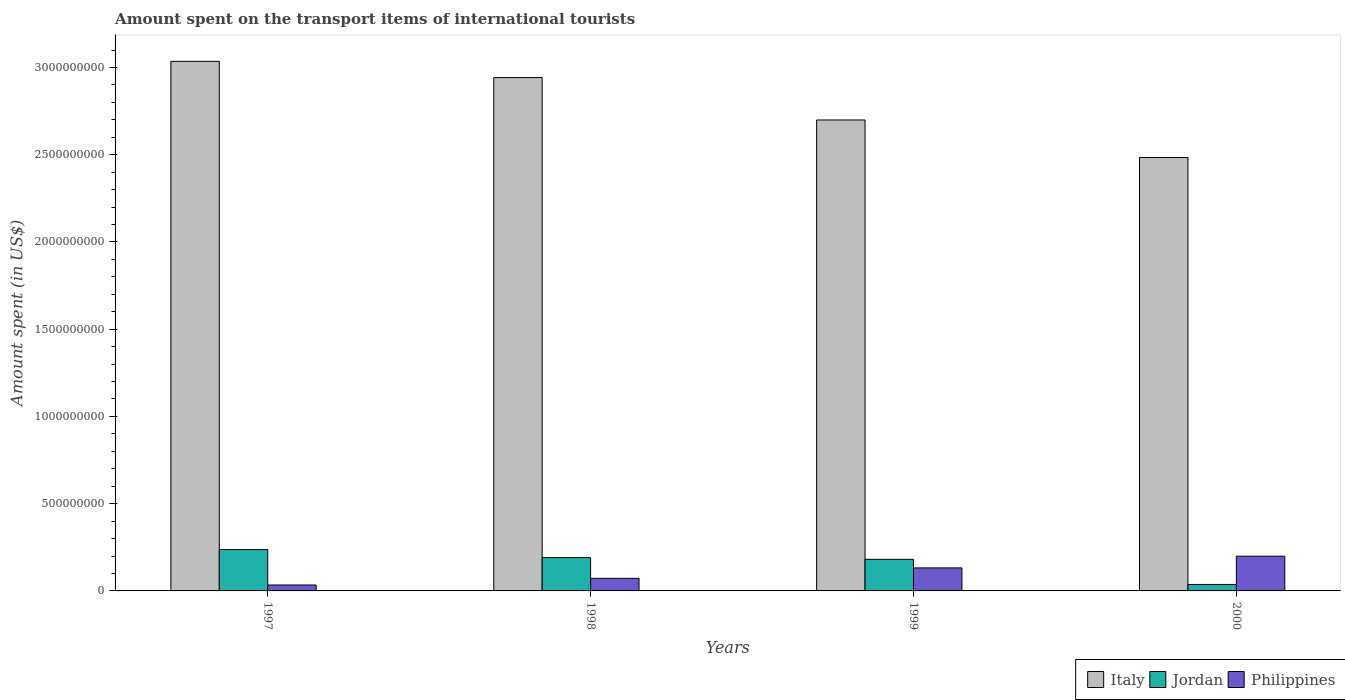How many groups of bars are there?
Provide a succinct answer. 4. Are the number of bars on each tick of the X-axis equal?
Provide a short and direct response. Yes. What is the label of the 3rd group of bars from the left?
Your response must be concise. 1999. What is the amount spent on the transport items of international tourists in Philippines in 1999?
Ensure brevity in your answer.  1.32e+08. Across all years, what is the maximum amount spent on the transport items of international tourists in Italy?
Give a very brief answer. 3.04e+09. Across all years, what is the minimum amount spent on the transport items of international tourists in Jordan?
Provide a short and direct response. 3.70e+07. In which year was the amount spent on the transport items of international tourists in Jordan maximum?
Provide a succinct answer. 1997. What is the total amount spent on the transport items of international tourists in Jordan in the graph?
Your answer should be very brief. 6.46e+08. What is the difference between the amount spent on the transport items of international tourists in Jordan in 1997 and that in 2000?
Provide a succinct answer. 2.00e+08. What is the difference between the amount spent on the transport items of international tourists in Jordan in 1997 and the amount spent on the transport items of international tourists in Italy in 1998?
Your answer should be compact. -2.70e+09. What is the average amount spent on the transport items of international tourists in Italy per year?
Make the answer very short. 2.79e+09. In the year 2000, what is the difference between the amount spent on the transport items of international tourists in Philippines and amount spent on the transport items of international tourists in Italy?
Give a very brief answer. -2.28e+09. What is the ratio of the amount spent on the transport items of international tourists in Philippines in 1998 to that in 1999?
Make the answer very short. 0.55. Is the difference between the amount spent on the transport items of international tourists in Philippines in 1998 and 2000 greater than the difference between the amount spent on the transport items of international tourists in Italy in 1998 and 2000?
Make the answer very short. No. What is the difference between the highest and the second highest amount spent on the transport items of international tourists in Jordan?
Make the answer very short. 4.60e+07. What is the difference between the highest and the lowest amount spent on the transport items of international tourists in Jordan?
Provide a short and direct response. 2.00e+08. What does the 1st bar from the right in 1998 represents?
Your answer should be compact. Philippines. Are all the bars in the graph horizontal?
Offer a very short reply. No. How many years are there in the graph?
Make the answer very short. 4. Are the values on the major ticks of Y-axis written in scientific E-notation?
Keep it short and to the point. No. How many legend labels are there?
Offer a terse response. 3. What is the title of the graph?
Your answer should be very brief. Amount spent on the transport items of international tourists. What is the label or title of the Y-axis?
Give a very brief answer. Amount spent (in US$). What is the Amount spent (in US$) in Italy in 1997?
Give a very brief answer. 3.04e+09. What is the Amount spent (in US$) in Jordan in 1997?
Give a very brief answer. 2.37e+08. What is the Amount spent (in US$) in Philippines in 1997?
Ensure brevity in your answer.  3.40e+07. What is the Amount spent (in US$) of Italy in 1998?
Your answer should be compact. 2.94e+09. What is the Amount spent (in US$) in Jordan in 1998?
Give a very brief answer. 1.91e+08. What is the Amount spent (in US$) in Philippines in 1998?
Your answer should be very brief. 7.20e+07. What is the Amount spent (in US$) of Italy in 1999?
Offer a very short reply. 2.70e+09. What is the Amount spent (in US$) of Jordan in 1999?
Offer a very short reply. 1.81e+08. What is the Amount spent (in US$) of Philippines in 1999?
Offer a terse response. 1.32e+08. What is the Amount spent (in US$) in Italy in 2000?
Offer a terse response. 2.48e+09. What is the Amount spent (in US$) in Jordan in 2000?
Give a very brief answer. 3.70e+07. What is the Amount spent (in US$) in Philippines in 2000?
Offer a very short reply. 1.99e+08. Across all years, what is the maximum Amount spent (in US$) in Italy?
Your response must be concise. 3.04e+09. Across all years, what is the maximum Amount spent (in US$) in Jordan?
Make the answer very short. 2.37e+08. Across all years, what is the maximum Amount spent (in US$) in Philippines?
Ensure brevity in your answer.  1.99e+08. Across all years, what is the minimum Amount spent (in US$) in Italy?
Your answer should be compact. 2.48e+09. Across all years, what is the minimum Amount spent (in US$) in Jordan?
Offer a very short reply. 3.70e+07. Across all years, what is the minimum Amount spent (in US$) in Philippines?
Your answer should be very brief. 3.40e+07. What is the total Amount spent (in US$) of Italy in the graph?
Offer a very short reply. 1.12e+1. What is the total Amount spent (in US$) in Jordan in the graph?
Make the answer very short. 6.46e+08. What is the total Amount spent (in US$) in Philippines in the graph?
Offer a very short reply. 4.37e+08. What is the difference between the Amount spent (in US$) in Italy in 1997 and that in 1998?
Your answer should be compact. 9.30e+07. What is the difference between the Amount spent (in US$) of Jordan in 1997 and that in 1998?
Your answer should be compact. 4.60e+07. What is the difference between the Amount spent (in US$) of Philippines in 1997 and that in 1998?
Your response must be concise. -3.80e+07. What is the difference between the Amount spent (in US$) of Italy in 1997 and that in 1999?
Provide a succinct answer. 3.36e+08. What is the difference between the Amount spent (in US$) in Jordan in 1997 and that in 1999?
Keep it short and to the point. 5.60e+07. What is the difference between the Amount spent (in US$) in Philippines in 1997 and that in 1999?
Provide a short and direct response. -9.80e+07. What is the difference between the Amount spent (in US$) of Italy in 1997 and that in 2000?
Provide a succinct answer. 5.51e+08. What is the difference between the Amount spent (in US$) of Philippines in 1997 and that in 2000?
Your response must be concise. -1.65e+08. What is the difference between the Amount spent (in US$) in Italy in 1998 and that in 1999?
Your answer should be very brief. 2.43e+08. What is the difference between the Amount spent (in US$) in Jordan in 1998 and that in 1999?
Your response must be concise. 1.00e+07. What is the difference between the Amount spent (in US$) in Philippines in 1998 and that in 1999?
Your response must be concise. -6.00e+07. What is the difference between the Amount spent (in US$) of Italy in 1998 and that in 2000?
Ensure brevity in your answer.  4.58e+08. What is the difference between the Amount spent (in US$) of Jordan in 1998 and that in 2000?
Make the answer very short. 1.54e+08. What is the difference between the Amount spent (in US$) in Philippines in 1998 and that in 2000?
Make the answer very short. -1.27e+08. What is the difference between the Amount spent (in US$) in Italy in 1999 and that in 2000?
Provide a short and direct response. 2.15e+08. What is the difference between the Amount spent (in US$) in Jordan in 1999 and that in 2000?
Your answer should be compact. 1.44e+08. What is the difference between the Amount spent (in US$) in Philippines in 1999 and that in 2000?
Your answer should be compact. -6.70e+07. What is the difference between the Amount spent (in US$) in Italy in 1997 and the Amount spent (in US$) in Jordan in 1998?
Your answer should be very brief. 2.84e+09. What is the difference between the Amount spent (in US$) in Italy in 1997 and the Amount spent (in US$) in Philippines in 1998?
Your answer should be compact. 2.96e+09. What is the difference between the Amount spent (in US$) of Jordan in 1997 and the Amount spent (in US$) of Philippines in 1998?
Your response must be concise. 1.65e+08. What is the difference between the Amount spent (in US$) in Italy in 1997 and the Amount spent (in US$) in Jordan in 1999?
Your answer should be compact. 2.85e+09. What is the difference between the Amount spent (in US$) in Italy in 1997 and the Amount spent (in US$) in Philippines in 1999?
Ensure brevity in your answer.  2.90e+09. What is the difference between the Amount spent (in US$) in Jordan in 1997 and the Amount spent (in US$) in Philippines in 1999?
Your answer should be compact. 1.05e+08. What is the difference between the Amount spent (in US$) in Italy in 1997 and the Amount spent (in US$) in Jordan in 2000?
Your answer should be very brief. 3.00e+09. What is the difference between the Amount spent (in US$) in Italy in 1997 and the Amount spent (in US$) in Philippines in 2000?
Provide a short and direct response. 2.84e+09. What is the difference between the Amount spent (in US$) of Jordan in 1997 and the Amount spent (in US$) of Philippines in 2000?
Offer a very short reply. 3.80e+07. What is the difference between the Amount spent (in US$) in Italy in 1998 and the Amount spent (in US$) in Jordan in 1999?
Offer a very short reply. 2.76e+09. What is the difference between the Amount spent (in US$) in Italy in 1998 and the Amount spent (in US$) in Philippines in 1999?
Offer a very short reply. 2.81e+09. What is the difference between the Amount spent (in US$) in Jordan in 1998 and the Amount spent (in US$) in Philippines in 1999?
Your answer should be very brief. 5.90e+07. What is the difference between the Amount spent (in US$) of Italy in 1998 and the Amount spent (in US$) of Jordan in 2000?
Provide a short and direct response. 2.90e+09. What is the difference between the Amount spent (in US$) in Italy in 1998 and the Amount spent (in US$) in Philippines in 2000?
Your answer should be very brief. 2.74e+09. What is the difference between the Amount spent (in US$) in Jordan in 1998 and the Amount spent (in US$) in Philippines in 2000?
Your response must be concise. -8.00e+06. What is the difference between the Amount spent (in US$) in Italy in 1999 and the Amount spent (in US$) in Jordan in 2000?
Provide a short and direct response. 2.66e+09. What is the difference between the Amount spent (in US$) of Italy in 1999 and the Amount spent (in US$) of Philippines in 2000?
Provide a short and direct response. 2.50e+09. What is the difference between the Amount spent (in US$) of Jordan in 1999 and the Amount spent (in US$) of Philippines in 2000?
Ensure brevity in your answer.  -1.80e+07. What is the average Amount spent (in US$) of Italy per year?
Provide a short and direct response. 2.79e+09. What is the average Amount spent (in US$) of Jordan per year?
Your response must be concise. 1.62e+08. What is the average Amount spent (in US$) in Philippines per year?
Ensure brevity in your answer.  1.09e+08. In the year 1997, what is the difference between the Amount spent (in US$) in Italy and Amount spent (in US$) in Jordan?
Provide a short and direct response. 2.80e+09. In the year 1997, what is the difference between the Amount spent (in US$) in Italy and Amount spent (in US$) in Philippines?
Give a very brief answer. 3.00e+09. In the year 1997, what is the difference between the Amount spent (in US$) in Jordan and Amount spent (in US$) in Philippines?
Provide a short and direct response. 2.03e+08. In the year 1998, what is the difference between the Amount spent (in US$) of Italy and Amount spent (in US$) of Jordan?
Your response must be concise. 2.75e+09. In the year 1998, what is the difference between the Amount spent (in US$) of Italy and Amount spent (in US$) of Philippines?
Your answer should be very brief. 2.87e+09. In the year 1998, what is the difference between the Amount spent (in US$) of Jordan and Amount spent (in US$) of Philippines?
Ensure brevity in your answer.  1.19e+08. In the year 1999, what is the difference between the Amount spent (in US$) in Italy and Amount spent (in US$) in Jordan?
Provide a short and direct response. 2.52e+09. In the year 1999, what is the difference between the Amount spent (in US$) in Italy and Amount spent (in US$) in Philippines?
Your response must be concise. 2.57e+09. In the year 1999, what is the difference between the Amount spent (in US$) in Jordan and Amount spent (in US$) in Philippines?
Offer a terse response. 4.90e+07. In the year 2000, what is the difference between the Amount spent (in US$) of Italy and Amount spent (in US$) of Jordan?
Offer a terse response. 2.45e+09. In the year 2000, what is the difference between the Amount spent (in US$) of Italy and Amount spent (in US$) of Philippines?
Ensure brevity in your answer.  2.28e+09. In the year 2000, what is the difference between the Amount spent (in US$) of Jordan and Amount spent (in US$) of Philippines?
Your answer should be very brief. -1.62e+08. What is the ratio of the Amount spent (in US$) in Italy in 1997 to that in 1998?
Offer a terse response. 1.03. What is the ratio of the Amount spent (in US$) in Jordan in 1997 to that in 1998?
Offer a very short reply. 1.24. What is the ratio of the Amount spent (in US$) of Philippines in 1997 to that in 1998?
Offer a very short reply. 0.47. What is the ratio of the Amount spent (in US$) in Italy in 1997 to that in 1999?
Offer a very short reply. 1.12. What is the ratio of the Amount spent (in US$) of Jordan in 1997 to that in 1999?
Your answer should be compact. 1.31. What is the ratio of the Amount spent (in US$) of Philippines in 1997 to that in 1999?
Give a very brief answer. 0.26. What is the ratio of the Amount spent (in US$) of Italy in 1997 to that in 2000?
Give a very brief answer. 1.22. What is the ratio of the Amount spent (in US$) of Jordan in 1997 to that in 2000?
Offer a very short reply. 6.41. What is the ratio of the Amount spent (in US$) in Philippines in 1997 to that in 2000?
Provide a succinct answer. 0.17. What is the ratio of the Amount spent (in US$) in Italy in 1998 to that in 1999?
Offer a very short reply. 1.09. What is the ratio of the Amount spent (in US$) of Jordan in 1998 to that in 1999?
Provide a short and direct response. 1.06. What is the ratio of the Amount spent (in US$) of Philippines in 1998 to that in 1999?
Provide a short and direct response. 0.55. What is the ratio of the Amount spent (in US$) of Italy in 1998 to that in 2000?
Your answer should be compact. 1.18. What is the ratio of the Amount spent (in US$) in Jordan in 1998 to that in 2000?
Ensure brevity in your answer.  5.16. What is the ratio of the Amount spent (in US$) of Philippines in 1998 to that in 2000?
Offer a terse response. 0.36. What is the ratio of the Amount spent (in US$) in Italy in 1999 to that in 2000?
Your answer should be compact. 1.09. What is the ratio of the Amount spent (in US$) in Jordan in 1999 to that in 2000?
Keep it short and to the point. 4.89. What is the ratio of the Amount spent (in US$) in Philippines in 1999 to that in 2000?
Make the answer very short. 0.66. What is the difference between the highest and the second highest Amount spent (in US$) in Italy?
Give a very brief answer. 9.30e+07. What is the difference between the highest and the second highest Amount spent (in US$) of Jordan?
Your answer should be compact. 4.60e+07. What is the difference between the highest and the second highest Amount spent (in US$) of Philippines?
Provide a short and direct response. 6.70e+07. What is the difference between the highest and the lowest Amount spent (in US$) of Italy?
Your answer should be very brief. 5.51e+08. What is the difference between the highest and the lowest Amount spent (in US$) in Jordan?
Give a very brief answer. 2.00e+08. What is the difference between the highest and the lowest Amount spent (in US$) of Philippines?
Offer a very short reply. 1.65e+08. 